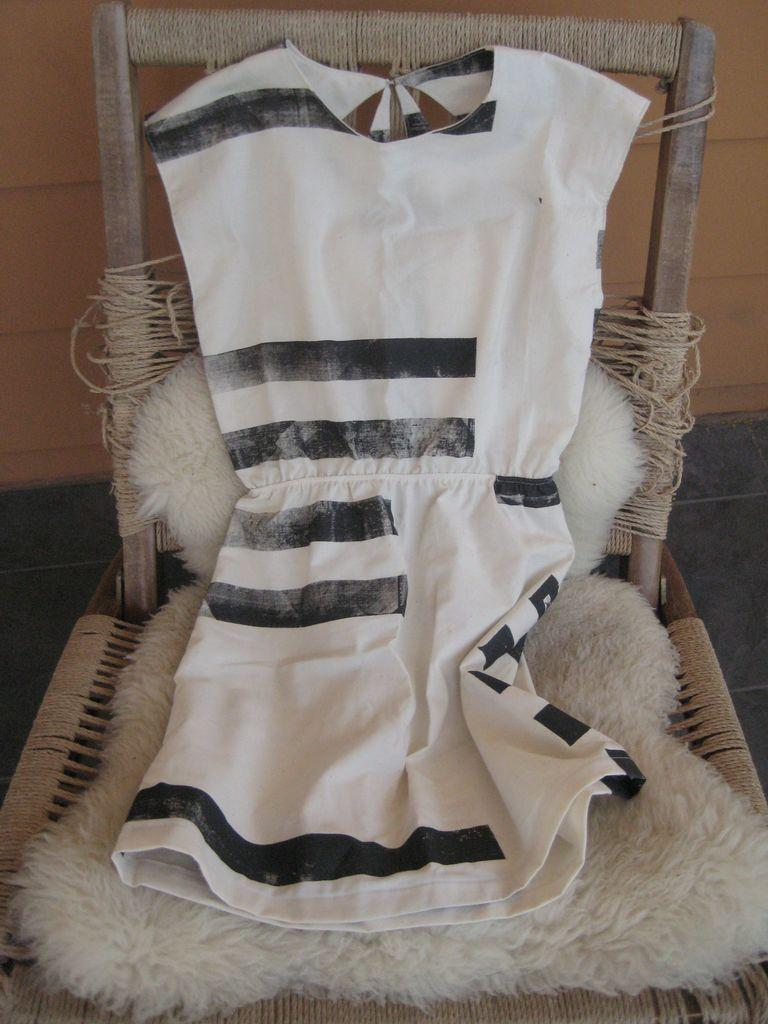What is located in the middle of the image? There is a chair in the middle of the image. What is on the chair? There is a white cloth on the chair. What can be seen in the background of the image? There is a wall in the background of the image. What type of soda is being served at the meeting in the image? There is no meeting or soda present in the image; it only features a chair with a white cloth and a wall in the background. 